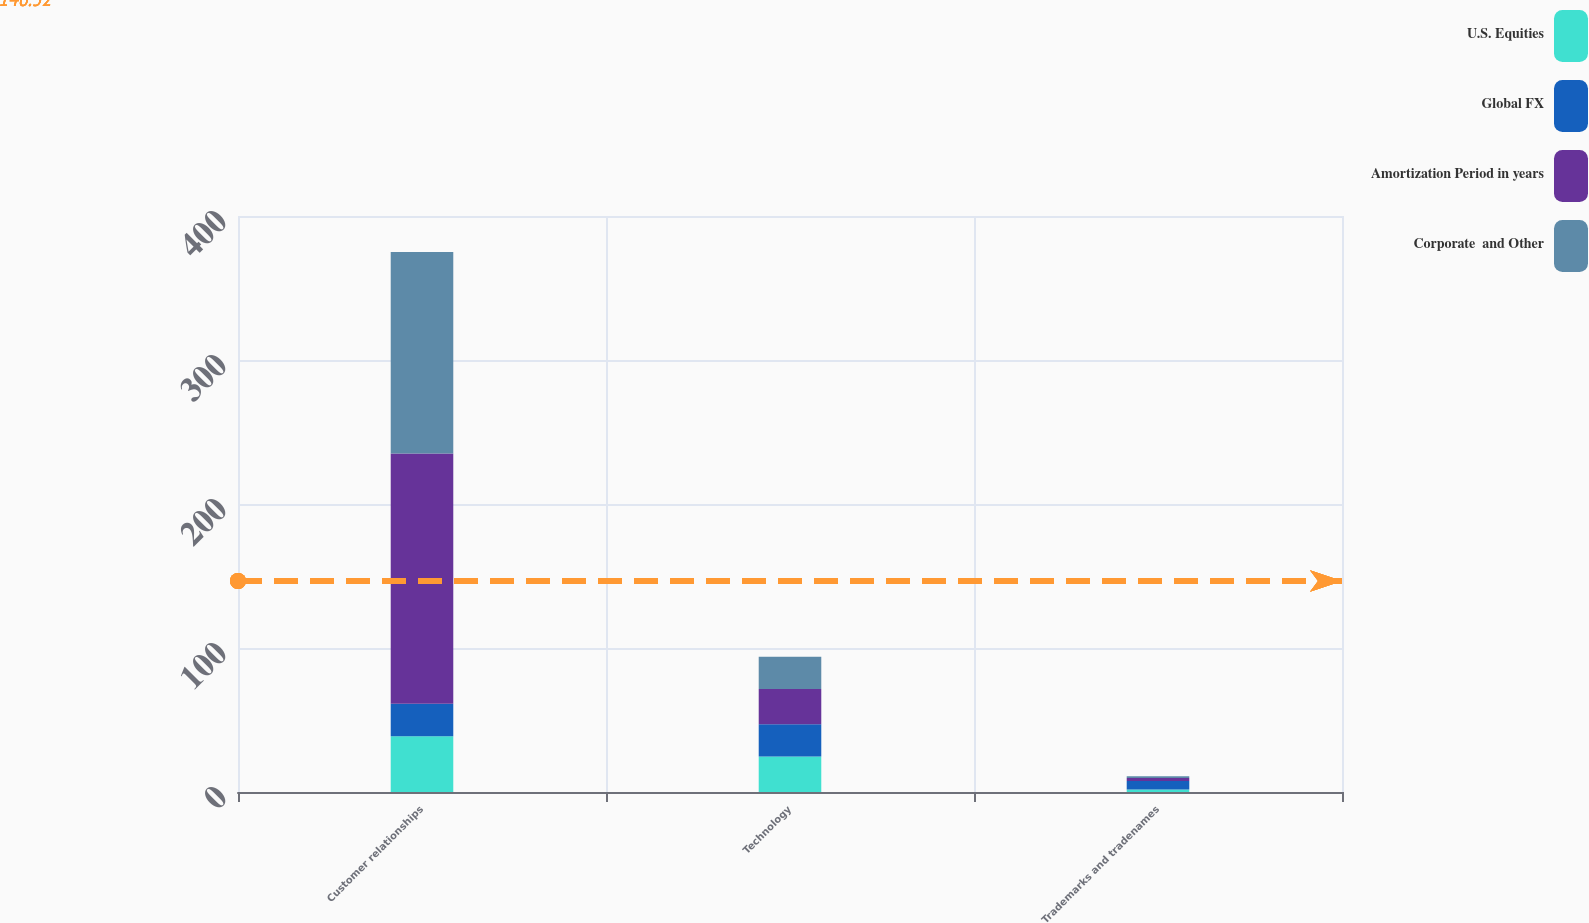<chart> <loc_0><loc_0><loc_500><loc_500><stacked_bar_chart><ecel><fcel>Customer relationships<fcel>Technology<fcel>Trademarks and tradenames<nl><fcel>U.S. Equities<fcel>38.8<fcel>24.6<fcel>1.7<nl><fcel>Global FX<fcel>22.5<fcel>22.5<fcel>6<nl><fcel>Amortization Period in years<fcel>173.7<fcel>24.4<fcel>2<nl><fcel>Corporate  and Other<fcel>140<fcel>22.5<fcel>1.2<nl></chart> 